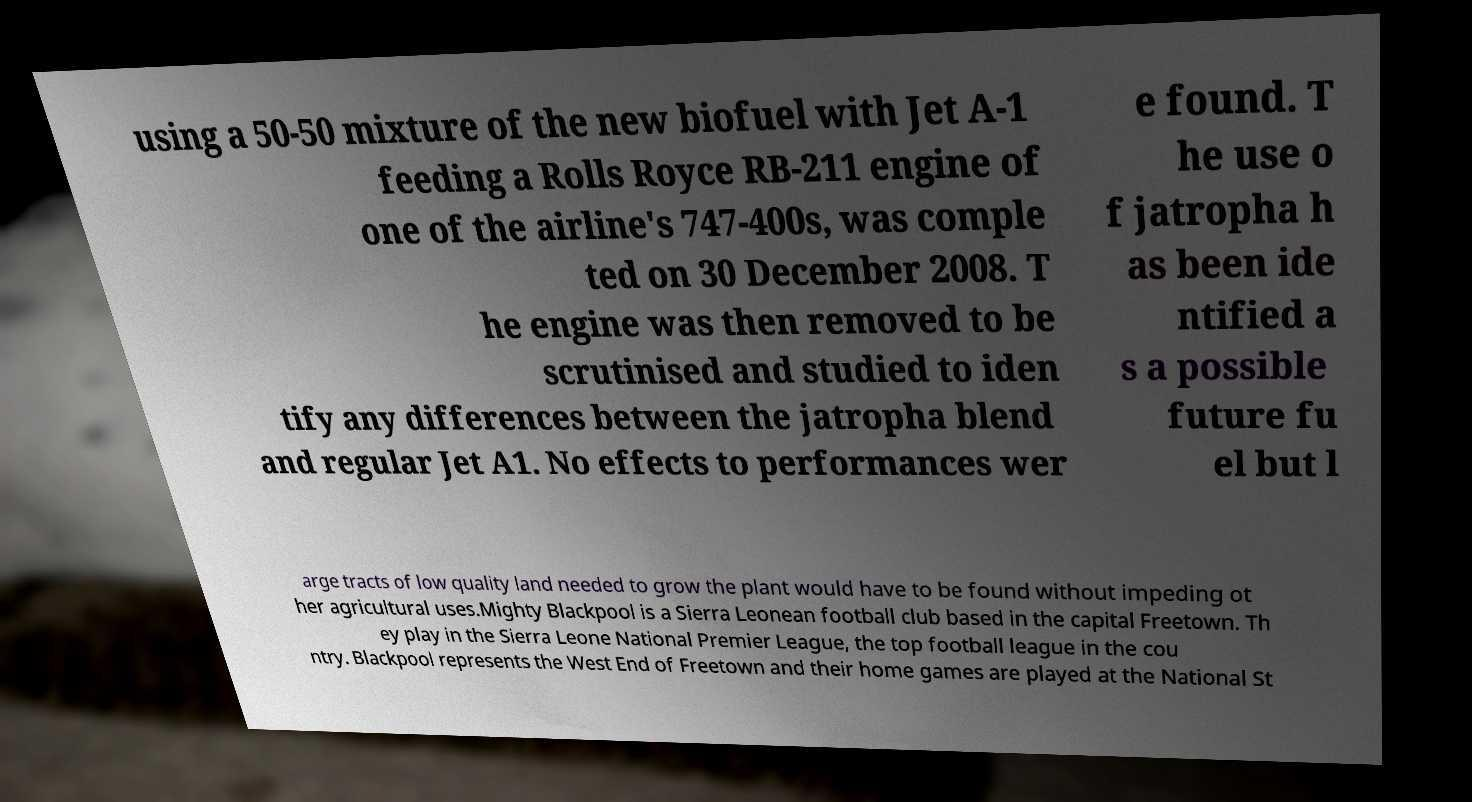Could you extract and type out the text from this image? using a 50-50 mixture of the new biofuel with Jet A-1 feeding a Rolls Royce RB-211 engine of one of the airline's 747-400s, was comple ted on 30 December 2008. T he engine was then removed to be scrutinised and studied to iden tify any differences between the jatropha blend and regular Jet A1. No effects to performances wer e found. T he use o f jatropha h as been ide ntified a s a possible future fu el but l arge tracts of low quality land needed to grow the plant would have to be found without impeding ot her agricultural uses.Mighty Blackpool is a Sierra Leonean football club based in the capital Freetown. Th ey play in the Sierra Leone National Premier League, the top football league in the cou ntry. Blackpool represents the West End of Freetown and their home games are played at the National St 